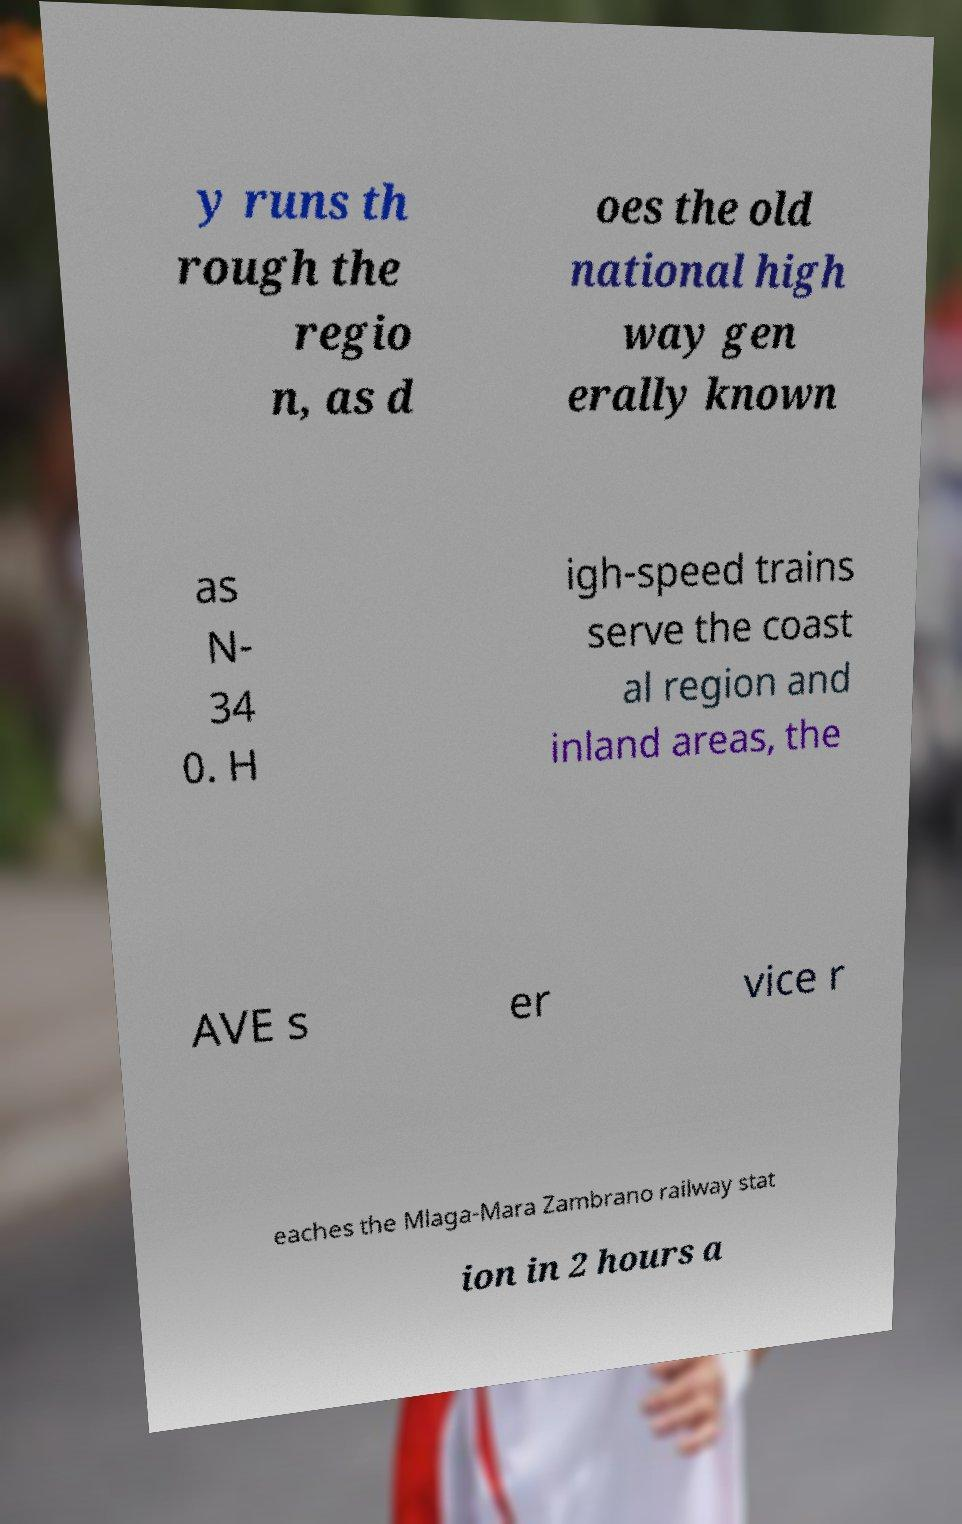Can you accurately transcribe the text from the provided image for me? y runs th rough the regio n, as d oes the old national high way gen erally known as N- 34 0. H igh-speed trains serve the coast al region and inland areas, the AVE s er vice r eaches the Mlaga-Mara Zambrano railway stat ion in 2 hours a 